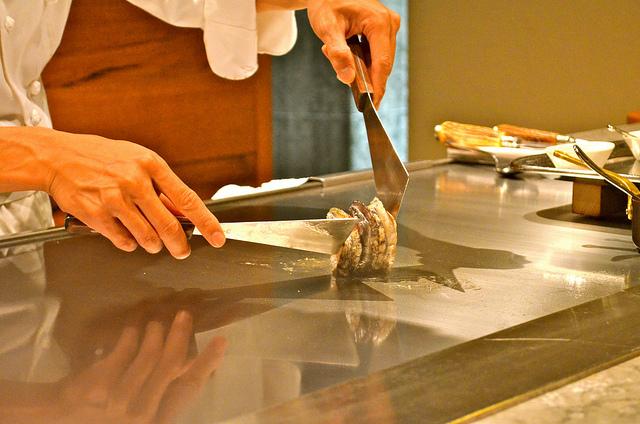What color is the shirt?
Give a very brief answer. White. Are there things in a person's hands?
Give a very brief answer. Yes. What is on the counter?
Short answer required. Food. 